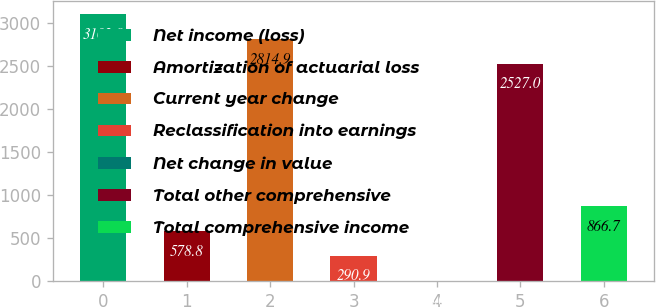Convert chart to OTSL. <chart><loc_0><loc_0><loc_500><loc_500><bar_chart><fcel>Net income (loss)<fcel>Amortization of actuarial loss<fcel>Current year change<fcel>Reclassification into earnings<fcel>Net change in value<fcel>Total other comprehensive<fcel>Total comprehensive income<nl><fcel>3102.8<fcel>578.8<fcel>2814.9<fcel>290.9<fcel>3<fcel>2527<fcel>866.7<nl></chart> 